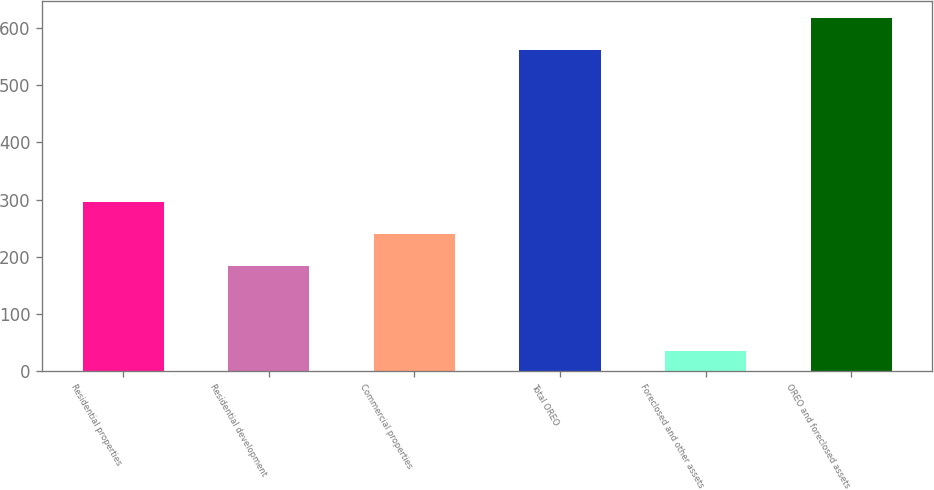Convert chart. <chart><loc_0><loc_0><loc_500><loc_500><bar_chart><fcel>Residential properties<fcel>Residential development<fcel>Commercial properties<fcel>Total OREO<fcel>Foreclosed and other assets<fcel>OREO and foreclosed assets<nl><fcel>295.2<fcel>183<fcel>239.1<fcel>561<fcel>35<fcel>617.1<nl></chart> 